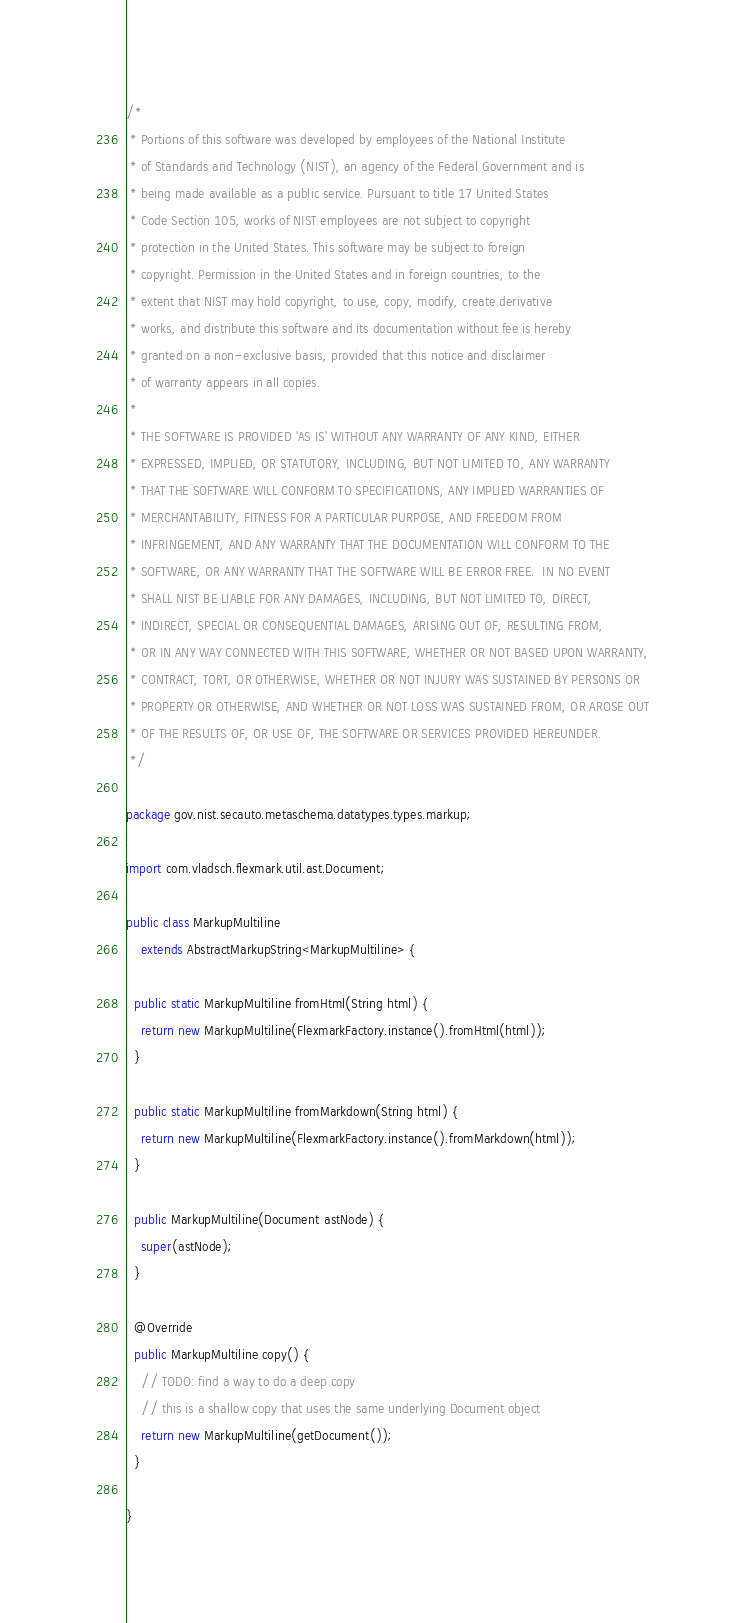<code> <loc_0><loc_0><loc_500><loc_500><_Java_>/*
 * Portions of this software was developed by employees of the National Institute
 * of Standards and Technology (NIST), an agency of the Federal Government and is
 * being made available as a public service. Pursuant to title 17 United States
 * Code Section 105, works of NIST employees are not subject to copyright
 * protection in the United States. This software may be subject to foreign
 * copyright. Permission in the United States and in foreign countries, to the
 * extent that NIST may hold copyright, to use, copy, modify, create derivative
 * works, and distribute this software and its documentation without fee is hereby
 * granted on a non-exclusive basis, provided that this notice and disclaimer
 * of warranty appears in all copies.
 *
 * THE SOFTWARE IS PROVIDED 'AS IS' WITHOUT ANY WARRANTY OF ANY KIND, EITHER
 * EXPRESSED, IMPLIED, OR STATUTORY, INCLUDING, BUT NOT LIMITED TO, ANY WARRANTY
 * THAT THE SOFTWARE WILL CONFORM TO SPECIFICATIONS, ANY IMPLIED WARRANTIES OF
 * MERCHANTABILITY, FITNESS FOR A PARTICULAR PURPOSE, AND FREEDOM FROM
 * INFRINGEMENT, AND ANY WARRANTY THAT THE DOCUMENTATION WILL CONFORM TO THE
 * SOFTWARE, OR ANY WARRANTY THAT THE SOFTWARE WILL BE ERROR FREE.  IN NO EVENT
 * SHALL NIST BE LIABLE FOR ANY DAMAGES, INCLUDING, BUT NOT LIMITED TO, DIRECT,
 * INDIRECT, SPECIAL OR CONSEQUENTIAL DAMAGES, ARISING OUT OF, RESULTING FROM,
 * OR IN ANY WAY CONNECTED WITH THIS SOFTWARE, WHETHER OR NOT BASED UPON WARRANTY,
 * CONTRACT, TORT, OR OTHERWISE, WHETHER OR NOT INJURY WAS SUSTAINED BY PERSONS OR
 * PROPERTY OR OTHERWISE, AND WHETHER OR NOT LOSS WAS SUSTAINED FROM, OR AROSE OUT
 * OF THE RESULTS OF, OR USE OF, THE SOFTWARE OR SERVICES PROVIDED HEREUNDER.
 */

package gov.nist.secauto.metaschema.datatypes.types.markup;

import com.vladsch.flexmark.util.ast.Document;

public class MarkupMultiline
    extends AbstractMarkupString<MarkupMultiline> {

  public static MarkupMultiline fromHtml(String html) {
    return new MarkupMultiline(FlexmarkFactory.instance().fromHtml(html));
  }

  public static MarkupMultiline fromMarkdown(String html) {
    return new MarkupMultiline(FlexmarkFactory.instance().fromMarkdown(html));
  }

  public MarkupMultiline(Document astNode) {
    super(astNode);
  }

  @Override
  public MarkupMultiline copy() {
    // TODO: find a way to do a deep copy
    // this is a shallow copy that uses the same underlying Document object
    return new MarkupMultiline(getDocument());
  }

}
</code> 